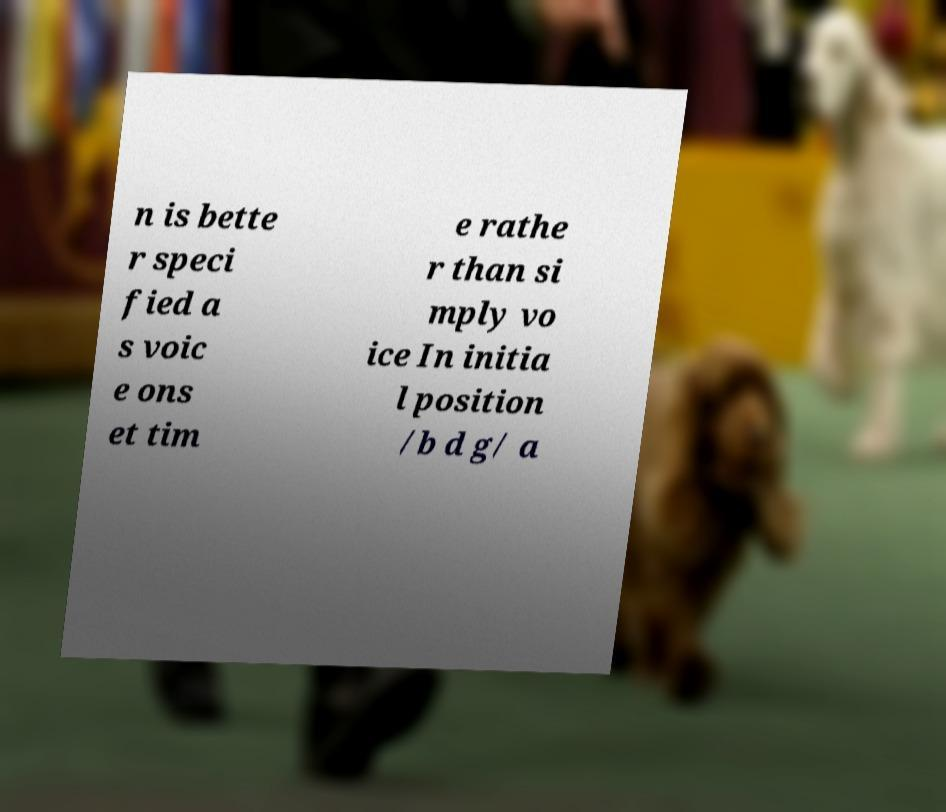What messages or text are displayed in this image? I need them in a readable, typed format. n is bette r speci fied a s voic e ons et tim e rathe r than si mply vo ice In initia l position /b d g/ a 